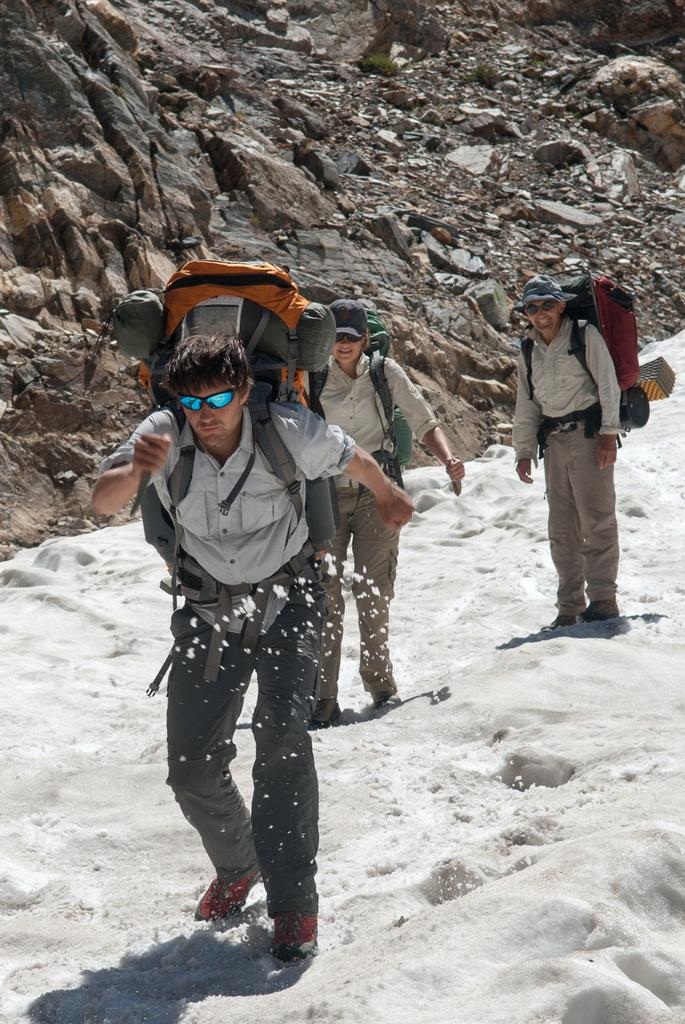How many people are in the image? There are three people standing in the image. What are the people wearing on their backs? The people are wearing backpack bags. What type of clothing are the people wearing on their upper bodies? The people are wearing shirts. What type of clothing are the people wearing on their lower bodies? The people are wearing trousers. What type of footwear are the people wearing? The people are wearing shoes. What can be observed about the environment in the image? The image appears to depict a snowy environment. What geographical feature is visible in the image? There is a mountain with rocks visible in the image. What rhythm is the father playing on the mountain in the image? There is no father or musical instrument present in the image, so it is not possible to determine if any rhythm is being played. 